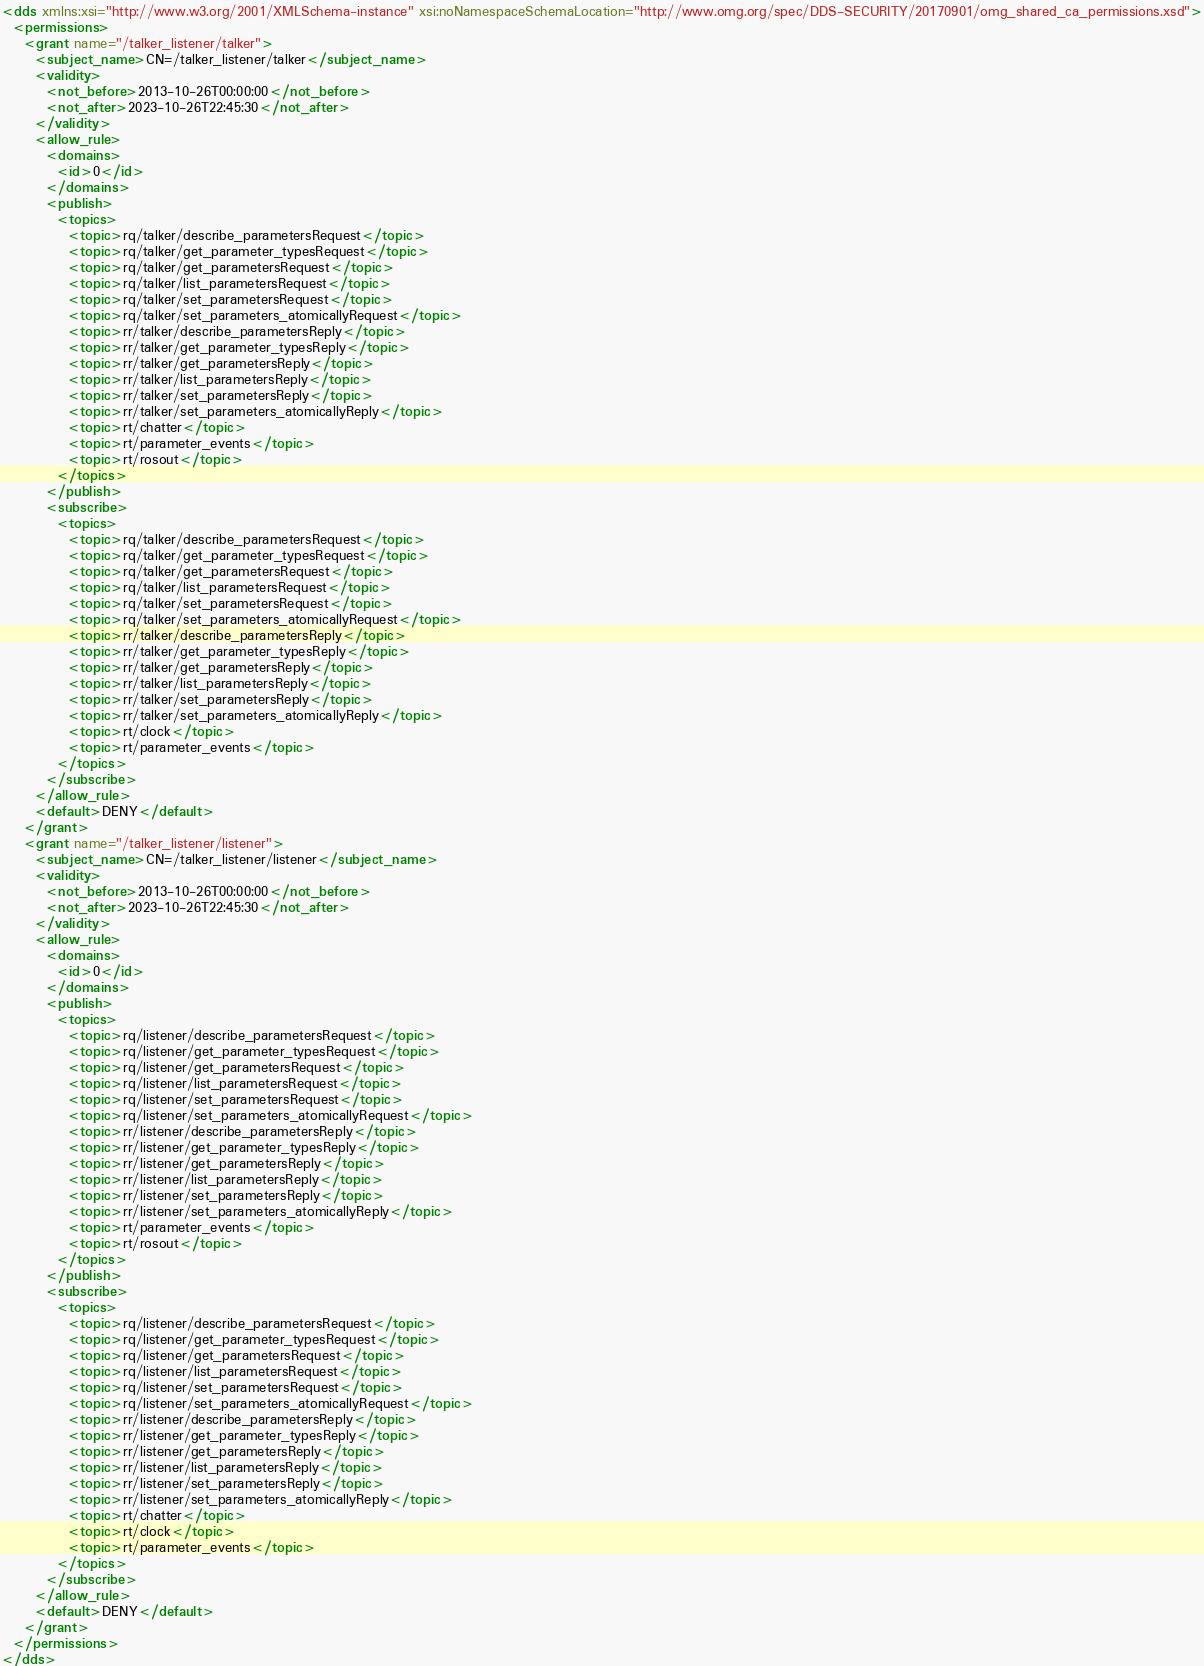Convert code to text. <code><loc_0><loc_0><loc_500><loc_500><_XML_><dds xmlns:xsi="http://www.w3.org/2001/XMLSchema-instance" xsi:noNamespaceSchemaLocation="http://www.omg.org/spec/DDS-SECURITY/20170901/omg_shared_ca_permissions.xsd">
  <permissions>
    <grant name="/talker_listener/talker">
      <subject_name>CN=/talker_listener/talker</subject_name>
      <validity>
        <not_before>2013-10-26T00:00:00</not_before>
        <not_after>2023-10-26T22:45:30</not_after>
      </validity>
      <allow_rule>
        <domains>
          <id>0</id>
        </domains>
        <publish>
          <topics>
            <topic>rq/talker/describe_parametersRequest</topic>
            <topic>rq/talker/get_parameter_typesRequest</topic>
            <topic>rq/talker/get_parametersRequest</topic>
            <topic>rq/talker/list_parametersRequest</topic>
            <topic>rq/talker/set_parametersRequest</topic>
            <topic>rq/talker/set_parameters_atomicallyRequest</topic>
            <topic>rr/talker/describe_parametersReply</topic>
            <topic>rr/talker/get_parameter_typesReply</topic>
            <topic>rr/talker/get_parametersReply</topic>
            <topic>rr/talker/list_parametersReply</topic>
            <topic>rr/talker/set_parametersReply</topic>
            <topic>rr/talker/set_parameters_atomicallyReply</topic>
            <topic>rt/chatter</topic>
            <topic>rt/parameter_events</topic>
            <topic>rt/rosout</topic>
          </topics>
        </publish>
        <subscribe>
          <topics>
            <topic>rq/talker/describe_parametersRequest</topic>
            <topic>rq/talker/get_parameter_typesRequest</topic>
            <topic>rq/talker/get_parametersRequest</topic>
            <topic>rq/talker/list_parametersRequest</topic>
            <topic>rq/talker/set_parametersRequest</topic>
            <topic>rq/talker/set_parameters_atomicallyRequest</topic>
            <topic>rr/talker/describe_parametersReply</topic>
            <topic>rr/talker/get_parameter_typesReply</topic>
            <topic>rr/talker/get_parametersReply</topic>
            <topic>rr/talker/list_parametersReply</topic>
            <topic>rr/talker/set_parametersReply</topic>
            <topic>rr/talker/set_parameters_atomicallyReply</topic>
            <topic>rt/clock</topic>
            <topic>rt/parameter_events</topic>
          </topics>
        </subscribe>
      </allow_rule>
      <default>DENY</default>
    </grant>
    <grant name="/talker_listener/listener">
      <subject_name>CN=/talker_listener/listener</subject_name>
      <validity>
        <not_before>2013-10-26T00:00:00</not_before>
        <not_after>2023-10-26T22:45:30</not_after>
      </validity>
      <allow_rule>
        <domains>
          <id>0</id>
        </domains>
        <publish>
          <topics>
            <topic>rq/listener/describe_parametersRequest</topic>
            <topic>rq/listener/get_parameter_typesRequest</topic>
            <topic>rq/listener/get_parametersRequest</topic>
            <topic>rq/listener/list_parametersRequest</topic>
            <topic>rq/listener/set_parametersRequest</topic>
            <topic>rq/listener/set_parameters_atomicallyRequest</topic>
            <topic>rr/listener/describe_parametersReply</topic>
            <topic>rr/listener/get_parameter_typesReply</topic>
            <topic>rr/listener/get_parametersReply</topic>
            <topic>rr/listener/list_parametersReply</topic>
            <topic>rr/listener/set_parametersReply</topic>
            <topic>rr/listener/set_parameters_atomicallyReply</topic>
            <topic>rt/parameter_events</topic>
            <topic>rt/rosout</topic>
          </topics>
        </publish>
        <subscribe>
          <topics>
            <topic>rq/listener/describe_parametersRequest</topic>
            <topic>rq/listener/get_parameter_typesRequest</topic>
            <topic>rq/listener/get_parametersRequest</topic>
            <topic>rq/listener/list_parametersRequest</topic>
            <topic>rq/listener/set_parametersRequest</topic>
            <topic>rq/listener/set_parameters_atomicallyRequest</topic>
            <topic>rr/listener/describe_parametersReply</topic>
            <topic>rr/listener/get_parameter_typesReply</topic>
            <topic>rr/listener/get_parametersReply</topic>
            <topic>rr/listener/list_parametersReply</topic>
            <topic>rr/listener/set_parametersReply</topic>
            <topic>rr/listener/set_parameters_atomicallyReply</topic>
            <topic>rt/chatter</topic>
            <topic>rt/clock</topic>
            <topic>rt/parameter_events</topic>
          </topics>
        </subscribe>
      </allow_rule>
      <default>DENY</default>
    </grant>
  </permissions>
</dds>
</code> 